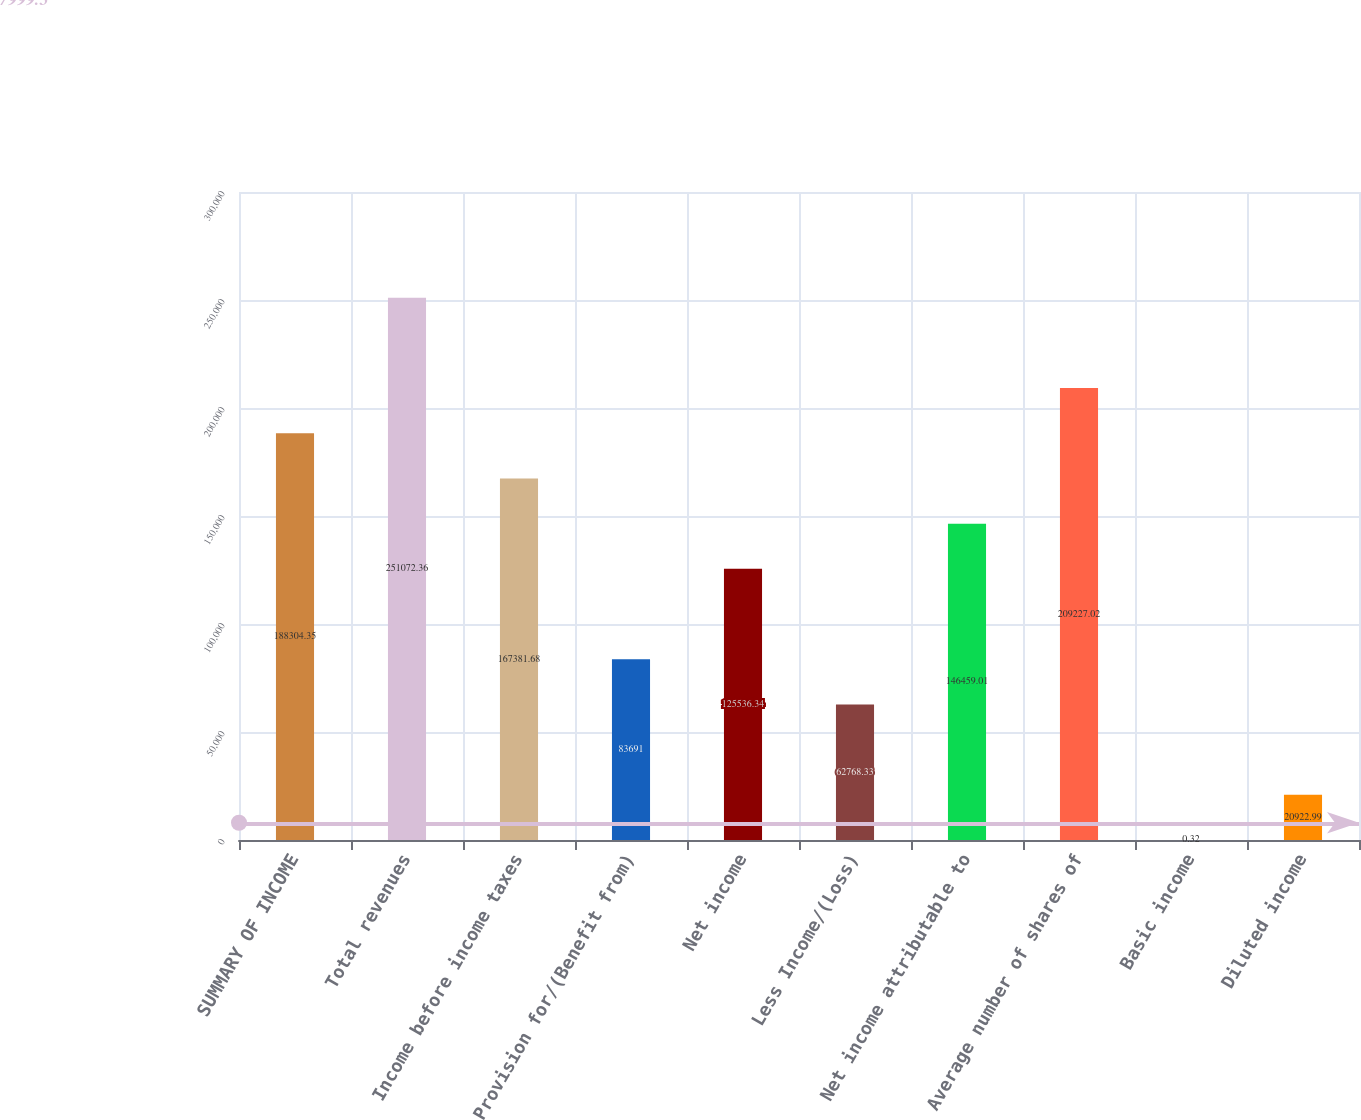Convert chart. <chart><loc_0><loc_0><loc_500><loc_500><bar_chart><fcel>SUMMARY OF INCOME<fcel>Total revenues<fcel>Income before income taxes<fcel>Provision for/(Benefit from)<fcel>Net income<fcel>Less Income/(Loss)<fcel>Net income attributable to<fcel>Average number of shares of<fcel>Basic income<fcel>Diluted income<nl><fcel>188304<fcel>251072<fcel>167382<fcel>83691<fcel>125536<fcel>62768.3<fcel>146459<fcel>209227<fcel>0.32<fcel>20923<nl></chart> 